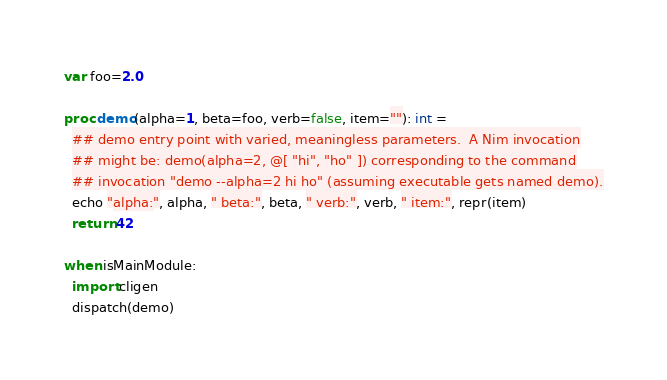Convert code to text. <code><loc_0><loc_0><loc_500><loc_500><_Nim_>var foo=2.0

proc demo(alpha=1, beta=foo, verb=false, item=""): int =
  ## demo entry point with varied, meaningless parameters.  A Nim invocation
  ## might be: demo(alpha=2, @[ "hi", "ho" ]) corresponding to the command
  ## invocation "demo --alpha=2 hi ho" (assuming executable gets named demo).
  echo "alpha:", alpha, " beta:", beta, " verb:", verb, " item:", repr(item)
  return 42

when isMainModule:
  import cligen
  dispatch(demo)
</code> 